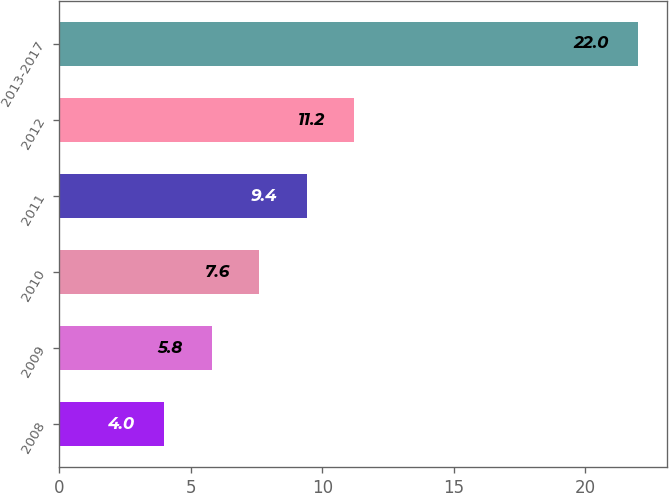Convert chart. <chart><loc_0><loc_0><loc_500><loc_500><bar_chart><fcel>2008<fcel>2009<fcel>2010<fcel>2011<fcel>2012<fcel>2013-2017<nl><fcel>4<fcel>5.8<fcel>7.6<fcel>9.4<fcel>11.2<fcel>22<nl></chart> 